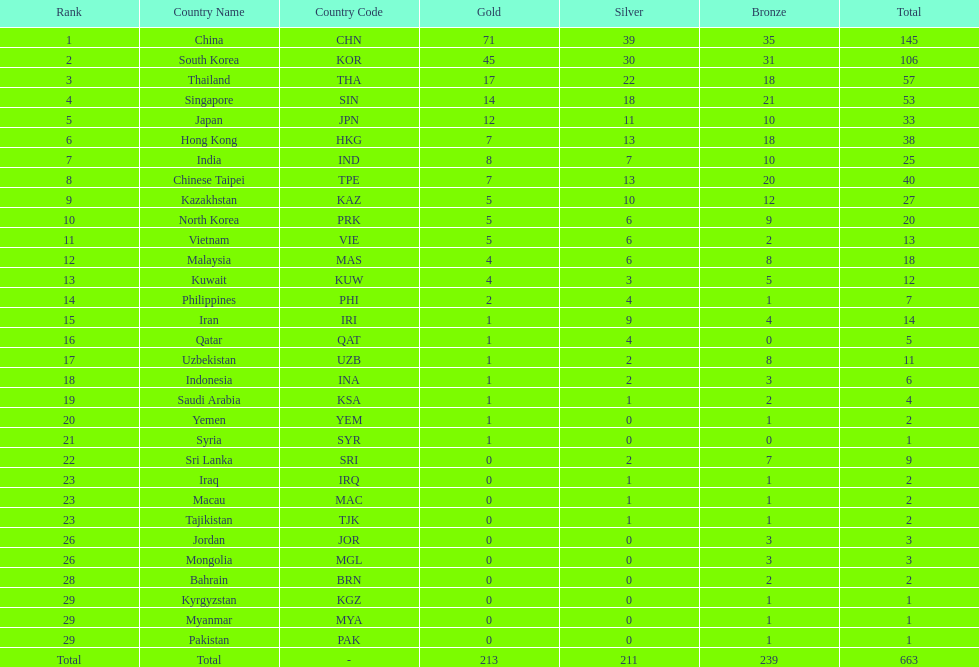Which nation has more gold medals, kuwait or india? India (IND). 